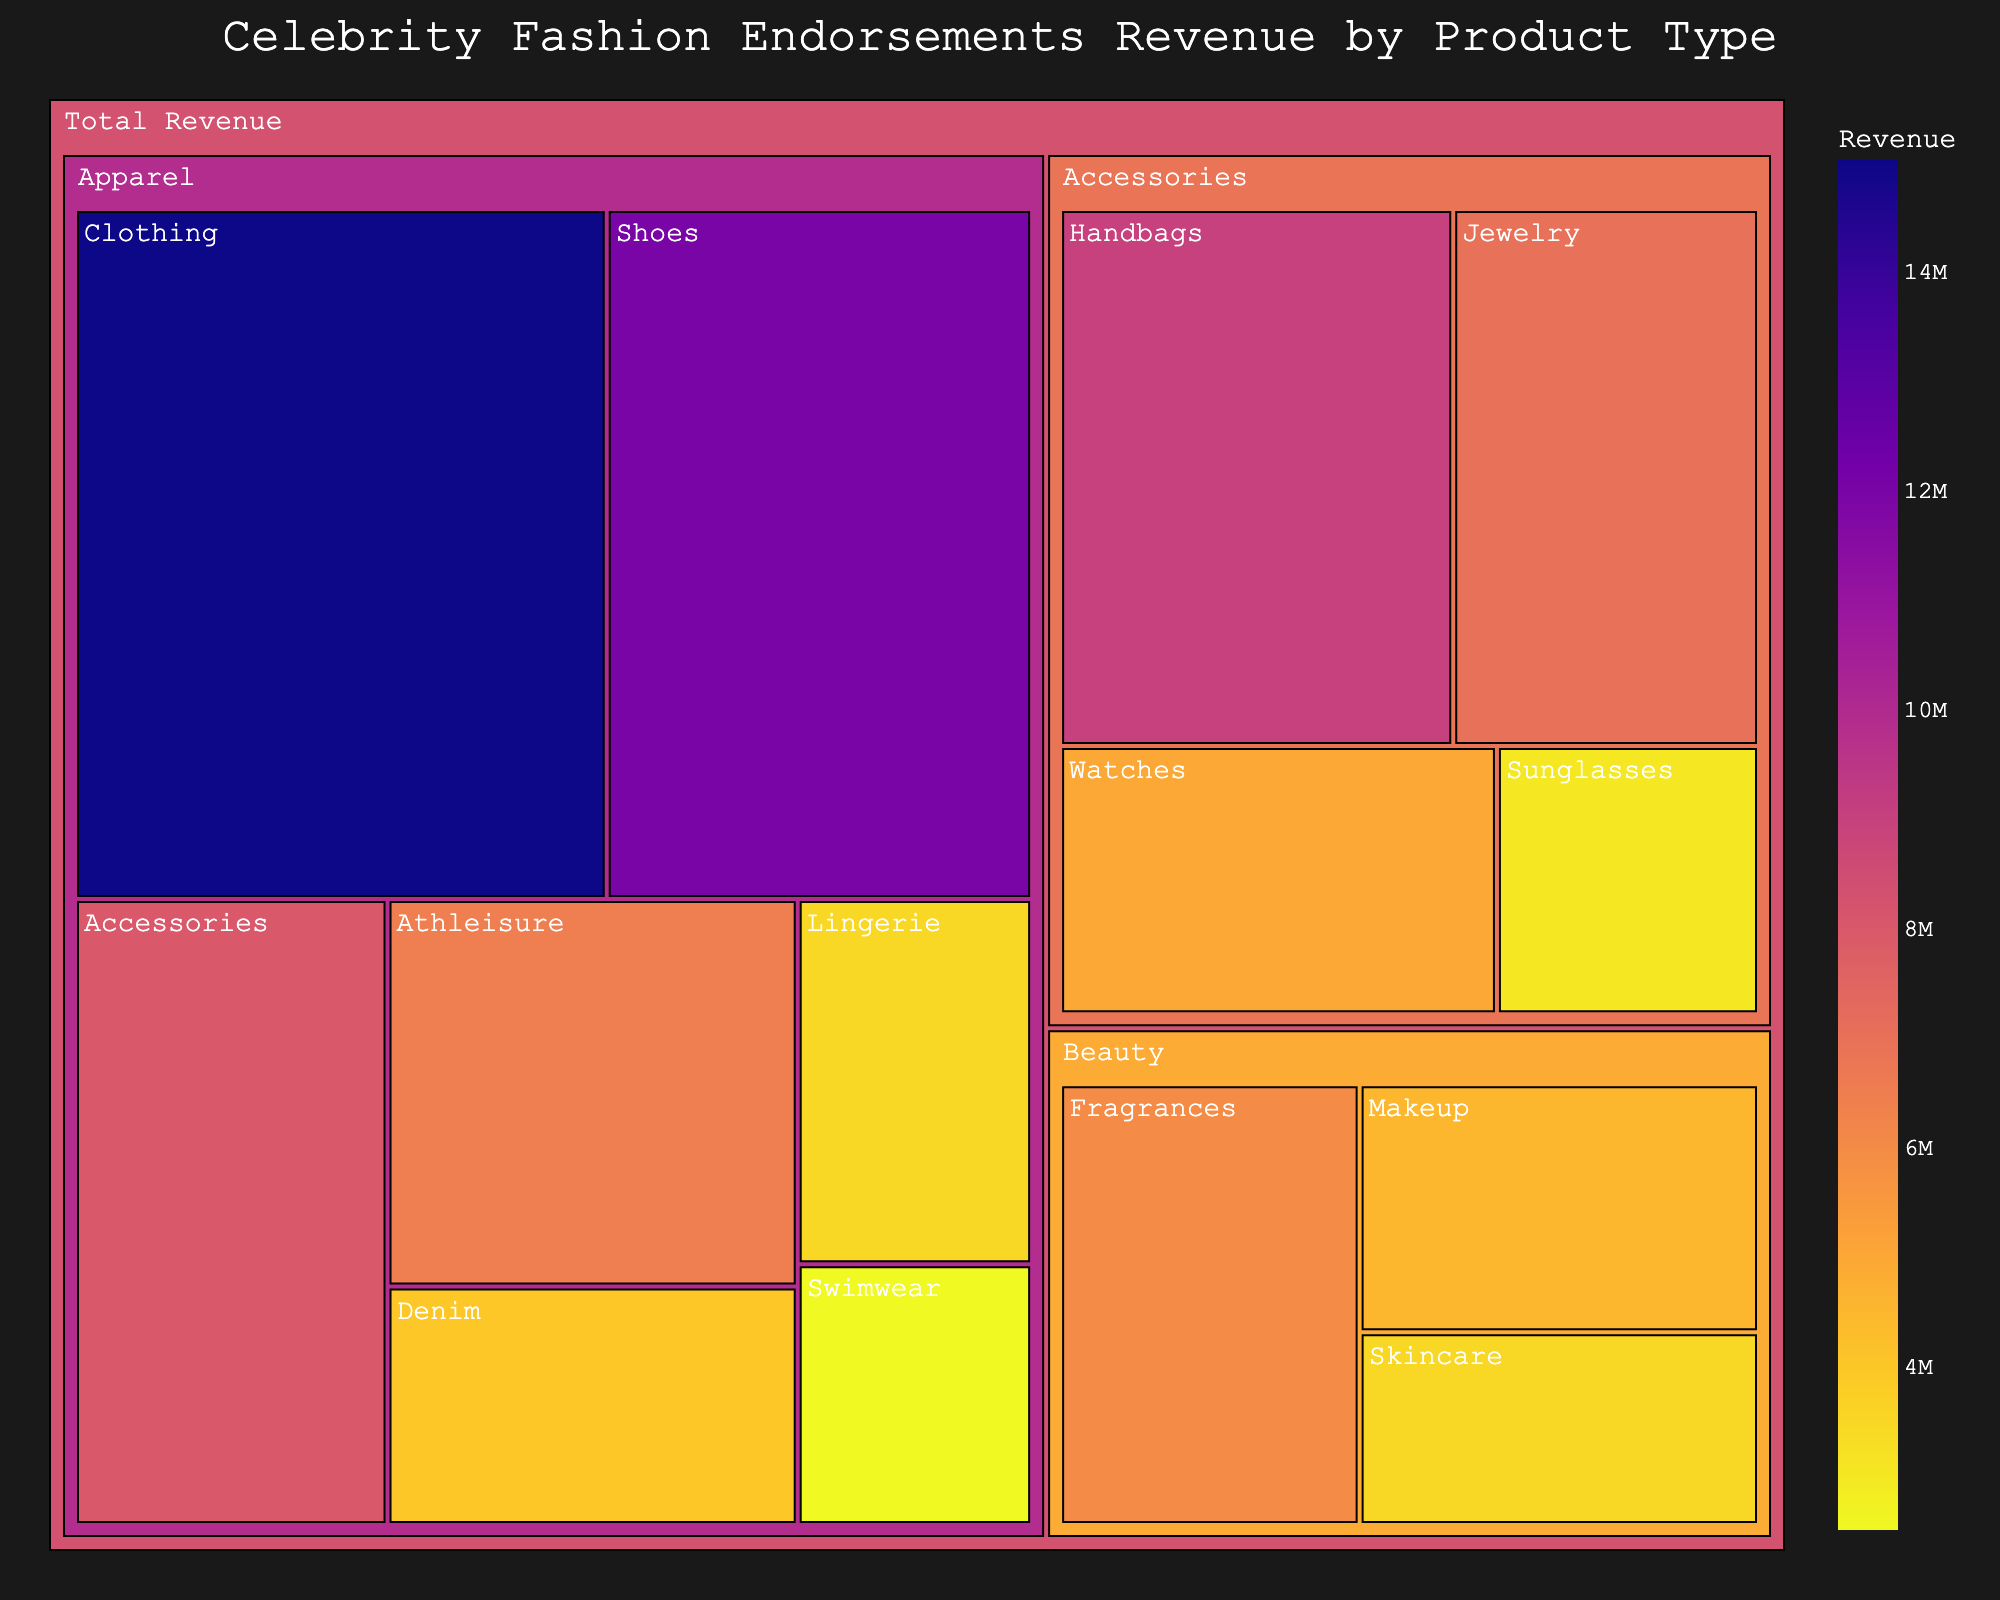How much revenue does the 'Clothing' product make? Locate the Apparel category in the treemap, then find the specific section for 'Clothing'. The revenue is shown as part of the label or in the hover data.
Answer: 15,000,000 What's the total revenue generated by the Beauty category? Sum the revenues of all products under the Beauty category: Fragrances (6,000,000) + Makeup (4,500,000) + Skincare (3,500,000).
Answer: 14,000,000 Which product within the Accessories category generates the most revenue? Within the Accessories category, compare the revenues of all listed products (Watches, Jewelry, Sunglasses, Handbags) by either label or hover data.
Answer: Handbags Are revenues from Shoes and Athleisure combined greater than revenues from Fragrances? Add the revenues from Shoes (12,000,000) and Athleisure (6,500,000) and compare with Fragrances (6,000,000). Shoes and Athleisure combined is 18,500,000, which is greater than 6,000,000.
Answer: Yes What is the least revenue-producing product in the Apparel category? Find the smallest revenue within the Apparel category by comparing all the products listed under it. Swimwear has the lowest revenue at 2,500,000.
Answer: Swimwear What's the difference in revenue between Jewelry and Watches? Subtract the revenue of Watches (5,000,000) from the revenue of Jewelry (7,000,000). The difference is 2,000,000.
Answer: 2,000,000 What is the color of the product category with the highest revenue? Identify the product category with the highest revenue, which is Clothing in Apparel. Locate its color on the color scale used in the treemap.
Answer: Darker shade (from the Plasma color scale) How many product groups are there under the Accessories category? Count each distinct product listed under the Accessories category in the treemap. The groups are Watches, Jewelry, Sunglasses, and Handbags.
Answer: 4 What is the ratio of the revenue from Makeup to Lingerie? Divide the revenue from Makeup (4,500,000) by the revenue from Lingerie (3,500,000). The ratio is approximately 1.29.
Answer: 1.29 